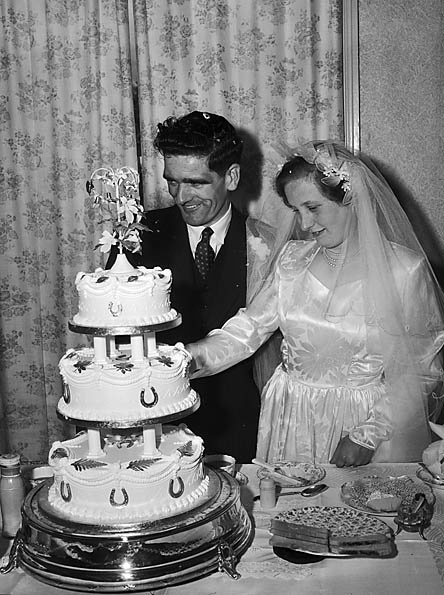Describe the objects in this image and their specific colors. I can see people in gray, darkgray, lightgray, and black tones, people in gray, black, darkgray, and lightgray tones, cake in gray, lightgray, darkgray, and black tones, cake in gray, lightgray, darkgray, and black tones, and cake in gray, lightgray, darkgray, and black tones in this image. 